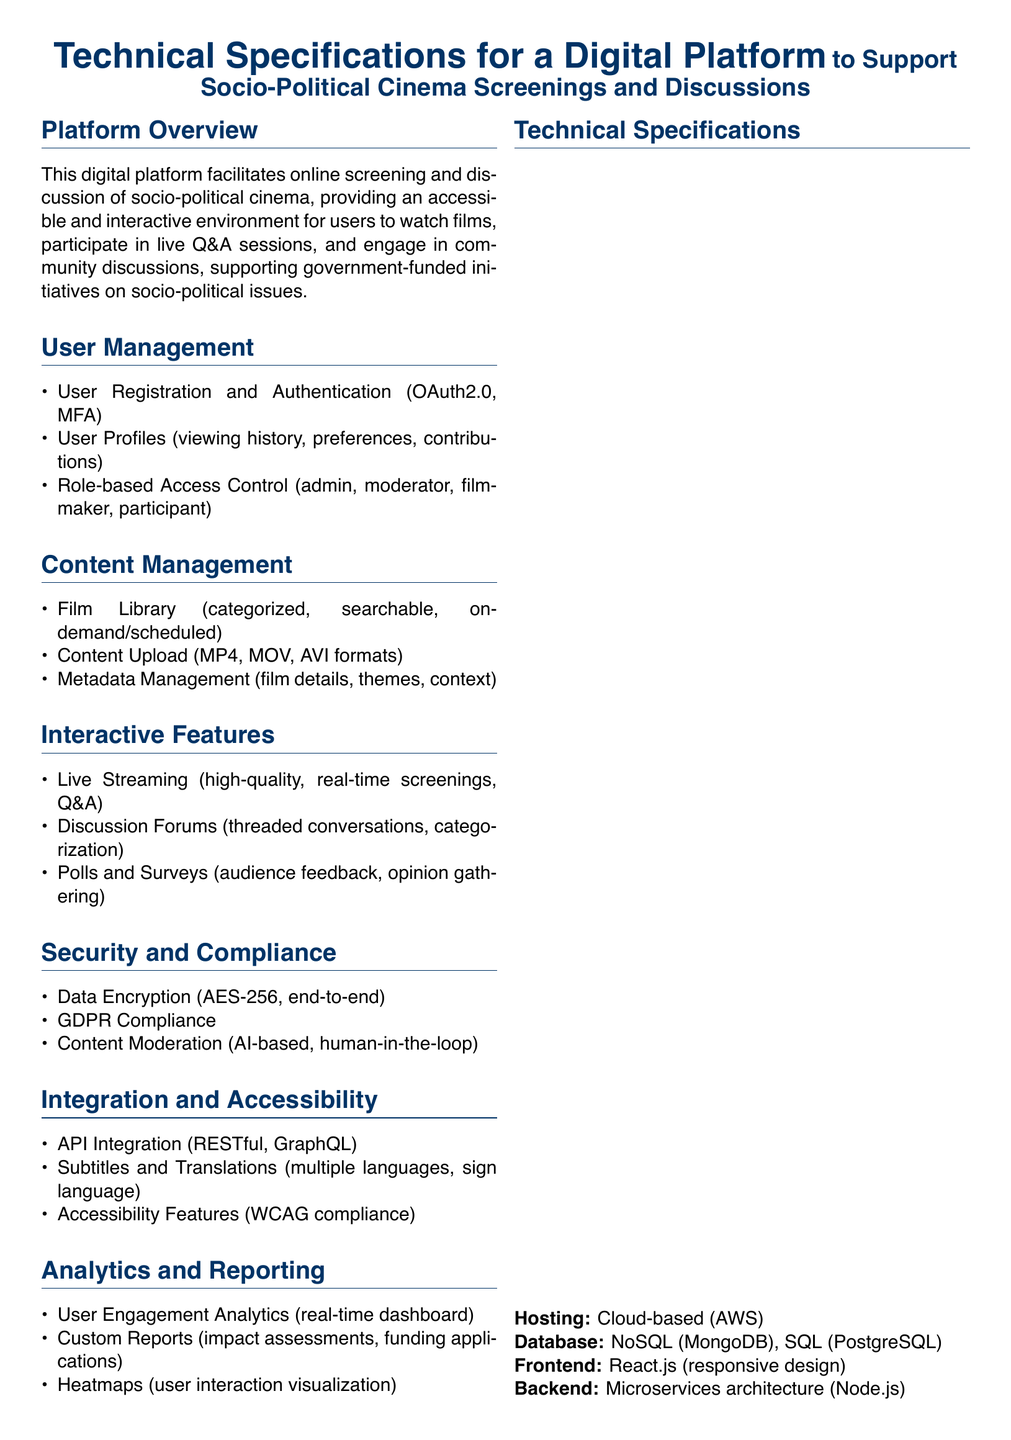What are the supported video formats for content upload? The supported video formats for content upload are MP4, MOV, and AVI.
Answer: MP4, MOV, AVI What is the encryption standard used for data security? The encryption standard used for data security is AES-256.
Answer: AES-256 How many user roles are mentioned in the document? The document mentions four user roles: admin, moderator, filmmaker, and participant.
Answer: Four What is the primary hosting service for the platform? The primary hosting service for the platform is AWS.
Answer: AWS What kind of analytics does the platform provide? The platform provides user engagement analytics, custom reports, and heatmaps.
Answer: User engagement analytics, custom reports, heatmaps What compliance does the platform adhere to regarding user data? The platform adheres to GDPR compliance regarding user data.
Answer: GDPR Compliance How does the platform ensure content moderation? The platform ensures content moderation through AI-based systems and human-in-the-loop processes.
Answer: AI-based, human-in-the-loop What is the database type mentioned for the platform? The document mentions both NoSQL (MongoDB) and SQL (PostgreSQL) as database types.
Answer: NoSQL (MongoDB), SQL (PostgreSQL) Which framework is used for the frontend development? The framework used for frontend development is React.js.
Answer: React.js 